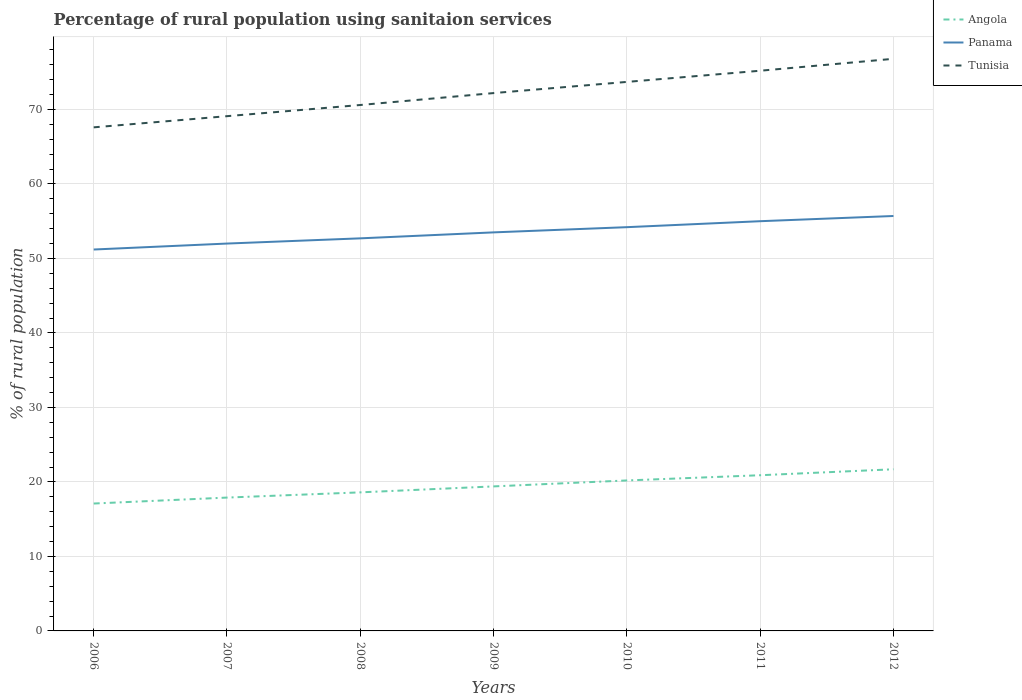How many different coloured lines are there?
Your answer should be very brief. 3. Is the number of lines equal to the number of legend labels?
Your answer should be very brief. Yes. Across all years, what is the maximum percentage of rural population using sanitaion services in Tunisia?
Your answer should be compact. 67.6. What is the total percentage of rural population using sanitaion services in Panama in the graph?
Your answer should be very brief. -0.8. What is the difference between the highest and the second highest percentage of rural population using sanitaion services in Tunisia?
Keep it short and to the point. 9.2. What is the difference between the highest and the lowest percentage of rural population using sanitaion services in Tunisia?
Keep it short and to the point. 4. Is the percentage of rural population using sanitaion services in Panama strictly greater than the percentage of rural population using sanitaion services in Tunisia over the years?
Provide a succinct answer. Yes. How many lines are there?
Keep it short and to the point. 3. How many years are there in the graph?
Your response must be concise. 7. How many legend labels are there?
Make the answer very short. 3. What is the title of the graph?
Provide a succinct answer. Percentage of rural population using sanitaion services. Does "Norway" appear as one of the legend labels in the graph?
Your response must be concise. No. What is the label or title of the Y-axis?
Offer a very short reply. % of rural population. What is the % of rural population in Angola in 2006?
Provide a succinct answer. 17.1. What is the % of rural population of Panama in 2006?
Offer a very short reply. 51.2. What is the % of rural population in Tunisia in 2006?
Provide a short and direct response. 67.6. What is the % of rural population of Tunisia in 2007?
Offer a very short reply. 69.1. What is the % of rural population in Panama in 2008?
Give a very brief answer. 52.7. What is the % of rural population of Tunisia in 2008?
Provide a succinct answer. 70.6. What is the % of rural population in Angola in 2009?
Your response must be concise. 19.4. What is the % of rural population in Panama in 2009?
Offer a very short reply. 53.5. What is the % of rural population of Tunisia in 2009?
Keep it short and to the point. 72.2. What is the % of rural population in Angola in 2010?
Your response must be concise. 20.2. What is the % of rural population of Panama in 2010?
Provide a succinct answer. 54.2. What is the % of rural population in Tunisia in 2010?
Your answer should be very brief. 73.7. What is the % of rural population in Angola in 2011?
Your answer should be compact. 20.9. What is the % of rural population of Panama in 2011?
Your response must be concise. 55. What is the % of rural population in Tunisia in 2011?
Your answer should be very brief. 75.2. What is the % of rural population of Angola in 2012?
Give a very brief answer. 21.7. What is the % of rural population of Panama in 2012?
Your answer should be compact. 55.7. What is the % of rural population in Tunisia in 2012?
Provide a succinct answer. 76.8. Across all years, what is the maximum % of rural population of Angola?
Your response must be concise. 21.7. Across all years, what is the maximum % of rural population in Panama?
Your answer should be compact. 55.7. Across all years, what is the maximum % of rural population in Tunisia?
Provide a succinct answer. 76.8. Across all years, what is the minimum % of rural population of Panama?
Offer a very short reply. 51.2. Across all years, what is the minimum % of rural population of Tunisia?
Give a very brief answer. 67.6. What is the total % of rural population in Angola in the graph?
Ensure brevity in your answer.  135.8. What is the total % of rural population in Panama in the graph?
Provide a succinct answer. 374.3. What is the total % of rural population of Tunisia in the graph?
Your answer should be very brief. 505.2. What is the difference between the % of rural population of Tunisia in 2006 and that in 2007?
Provide a succinct answer. -1.5. What is the difference between the % of rural population in Angola in 2006 and that in 2008?
Keep it short and to the point. -1.5. What is the difference between the % of rural population of Panama in 2006 and that in 2008?
Your response must be concise. -1.5. What is the difference between the % of rural population in Tunisia in 2006 and that in 2008?
Give a very brief answer. -3. What is the difference between the % of rural population of Panama in 2006 and that in 2009?
Your answer should be very brief. -2.3. What is the difference between the % of rural population of Angola in 2006 and that in 2010?
Your answer should be compact. -3.1. What is the difference between the % of rural population in Panama in 2006 and that in 2010?
Offer a terse response. -3. What is the difference between the % of rural population of Panama in 2006 and that in 2012?
Give a very brief answer. -4.5. What is the difference between the % of rural population in Panama in 2007 and that in 2008?
Offer a very short reply. -0.7. What is the difference between the % of rural population in Tunisia in 2007 and that in 2008?
Offer a very short reply. -1.5. What is the difference between the % of rural population of Panama in 2007 and that in 2009?
Your answer should be compact. -1.5. What is the difference between the % of rural population of Tunisia in 2007 and that in 2009?
Your response must be concise. -3.1. What is the difference between the % of rural population in Angola in 2007 and that in 2010?
Your answer should be compact. -2.3. What is the difference between the % of rural population of Tunisia in 2007 and that in 2010?
Provide a short and direct response. -4.6. What is the difference between the % of rural population in Angola in 2007 and that in 2011?
Your answer should be compact. -3. What is the difference between the % of rural population in Angola in 2007 and that in 2012?
Make the answer very short. -3.8. What is the difference between the % of rural population of Panama in 2007 and that in 2012?
Make the answer very short. -3.7. What is the difference between the % of rural population of Tunisia in 2007 and that in 2012?
Ensure brevity in your answer.  -7.7. What is the difference between the % of rural population in Panama in 2008 and that in 2009?
Offer a terse response. -0.8. What is the difference between the % of rural population of Tunisia in 2008 and that in 2009?
Ensure brevity in your answer.  -1.6. What is the difference between the % of rural population of Panama in 2008 and that in 2010?
Your response must be concise. -1.5. What is the difference between the % of rural population of Panama in 2008 and that in 2011?
Your answer should be compact. -2.3. What is the difference between the % of rural population of Angola in 2009 and that in 2010?
Offer a terse response. -0.8. What is the difference between the % of rural population of Panama in 2009 and that in 2011?
Ensure brevity in your answer.  -1.5. What is the difference between the % of rural population of Angola in 2009 and that in 2012?
Offer a very short reply. -2.3. What is the difference between the % of rural population of Panama in 2009 and that in 2012?
Make the answer very short. -2.2. What is the difference between the % of rural population in Tunisia in 2009 and that in 2012?
Give a very brief answer. -4.6. What is the difference between the % of rural population of Angola in 2010 and that in 2011?
Your response must be concise. -0.7. What is the difference between the % of rural population in Panama in 2010 and that in 2011?
Ensure brevity in your answer.  -0.8. What is the difference between the % of rural population of Tunisia in 2010 and that in 2011?
Provide a short and direct response. -1.5. What is the difference between the % of rural population in Angola in 2010 and that in 2012?
Offer a terse response. -1.5. What is the difference between the % of rural population in Panama in 2010 and that in 2012?
Your response must be concise. -1.5. What is the difference between the % of rural population in Tunisia in 2010 and that in 2012?
Provide a short and direct response. -3.1. What is the difference between the % of rural population of Angola in 2011 and that in 2012?
Your response must be concise. -0.8. What is the difference between the % of rural population of Tunisia in 2011 and that in 2012?
Your response must be concise. -1.6. What is the difference between the % of rural population in Angola in 2006 and the % of rural population in Panama in 2007?
Provide a succinct answer. -34.9. What is the difference between the % of rural population of Angola in 2006 and the % of rural population of Tunisia in 2007?
Your answer should be compact. -52. What is the difference between the % of rural population in Panama in 2006 and the % of rural population in Tunisia in 2007?
Provide a short and direct response. -17.9. What is the difference between the % of rural population of Angola in 2006 and the % of rural population of Panama in 2008?
Give a very brief answer. -35.6. What is the difference between the % of rural population in Angola in 2006 and the % of rural population in Tunisia in 2008?
Provide a short and direct response. -53.5. What is the difference between the % of rural population in Panama in 2006 and the % of rural population in Tunisia in 2008?
Your answer should be very brief. -19.4. What is the difference between the % of rural population of Angola in 2006 and the % of rural population of Panama in 2009?
Keep it short and to the point. -36.4. What is the difference between the % of rural population of Angola in 2006 and the % of rural population of Tunisia in 2009?
Give a very brief answer. -55.1. What is the difference between the % of rural population in Panama in 2006 and the % of rural population in Tunisia in 2009?
Make the answer very short. -21. What is the difference between the % of rural population of Angola in 2006 and the % of rural population of Panama in 2010?
Keep it short and to the point. -37.1. What is the difference between the % of rural population in Angola in 2006 and the % of rural population in Tunisia in 2010?
Keep it short and to the point. -56.6. What is the difference between the % of rural population of Panama in 2006 and the % of rural population of Tunisia in 2010?
Your answer should be very brief. -22.5. What is the difference between the % of rural population in Angola in 2006 and the % of rural population in Panama in 2011?
Give a very brief answer. -37.9. What is the difference between the % of rural population in Angola in 2006 and the % of rural population in Tunisia in 2011?
Ensure brevity in your answer.  -58.1. What is the difference between the % of rural population in Angola in 2006 and the % of rural population in Panama in 2012?
Offer a terse response. -38.6. What is the difference between the % of rural population in Angola in 2006 and the % of rural population in Tunisia in 2012?
Offer a terse response. -59.7. What is the difference between the % of rural population of Panama in 2006 and the % of rural population of Tunisia in 2012?
Provide a succinct answer. -25.6. What is the difference between the % of rural population in Angola in 2007 and the % of rural population in Panama in 2008?
Make the answer very short. -34.8. What is the difference between the % of rural population of Angola in 2007 and the % of rural population of Tunisia in 2008?
Give a very brief answer. -52.7. What is the difference between the % of rural population in Panama in 2007 and the % of rural population in Tunisia in 2008?
Your response must be concise. -18.6. What is the difference between the % of rural population of Angola in 2007 and the % of rural population of Panama in 2009?
Your answer should be compact. -35.6. What is the difference between the % of rural population in Angola in 2007 and the % of rural population in Tunisia in 2009?
Provide a succinct answer. -54.3. What is the difference between the % of rural population in Panama in 2007 and the % of rural population in Tunisia in 2009?
Provide a short and direct response. -20.2. What is the difference between the % of rural population of Angola in 2007 and the % of rural population of Panama in 2010?
Keep it short and to the point. -36.3. What is the difference between the % of rural population of Angola in 2007 and the % of rural population of Tunisia in 2010?
Your response must be concise. -55.8. What is the difference between the % of rural population in Panama in 2007 and the % of rural population in Tunisia in 2010?
Your response must be concise. -21.7. What is the difference between the % of rural population in Angola in 2007 and the % of rural population in Panama in 2011?
Provide a short and direct response. -37.1. What is the difference between the % of rural population of Angola in 2007 and the % of rural population of Tunisia in 2011?
Give a very brief answer. -57.3. What is the difference between the % of rural population in Panama in 2007 and the % of rural population in Tunisia in 2011?
Your answer should be compact. -23.2. What is the difference between the % of rural population of Angola in 2007 and the % of rural population of Panama in 2012?
Offer a terse response. -37.8. What is the difference between the % of rural population in Angola in 2007 and the % of rural population in Tunisia in 2012?
Ensure brevity in your answer.  -58.9. What is the difference between the % of rural population of Panama in 2007 and the % of rural population of Tunisia in 2012?
Provide a short and direct response. -24.8. What is the difference between the % of rural population of Angola in 2008 and the % of rural population of Panama in 2009?
Make the answer very short. -34.9. What is the difference between the % of rural population in Angola in 2008 and the % of rural population in Tunisia in 2009?
Your response must be concise. -53.6. What is the difference between the % of rural population of Panama in 2008 and the % of rural population of Tunisia in 2009?
Make the answer very short. -19.5. What is the difference between the % of rural population of Angola in 2008 and the % of rural population of Panama in 2010?
Provide a short and direct response. -35.6. What is the difference between the % of rural population of Angola in 2008 and the % of rural population of Tunisia in 2010?
Give a very brief answer. -55.1. What is the difference between the % of rural population of Angola in 2008 and the % of rural population of Panama in 2011?
Provide a short and direct response. -36.4. What is the difference between the % of rural population in Angola in 2008 and the % of rural population in Tunisia in 2011?
Your response must be concise. -56.6. What is the difference between the % of rural population in Panama in 2008 and the % of rural population in Tunisia in 2011?
Provide a short and direct response. -22.5. What is the difference between the % of rural population in Angola in 2008 and the % of rural population in Panama in 2012?
Provide a short and direct response. -37.1. What is the difference between the % of rural population of Angola in 2008 and the % of rural population of Tunisia in 2012?
Your response must be concise. -58.2. What is the difference between the % of rural population in Panama in 2008 and the % of rural population in Tunisia in 2012?
Provide a short and direct response. -24.1. What is the difference between the % of rural population in Angola in 2009 and the % of rural population in Panama in 2010?
Give a very brief answer. -34.8. What is the difference between the % of rural population in Angola in 2009 and the % of rural population in Tunisia in 2010?
Ensure brevity in your answer.  -54.3. What is the difference between the % of rural population of Panama in 2009 and the % of rural population of Tunisia in 2010?
Your response must be concise. -20.2. What is the difference between the % of rural population in Angola in 2009 and the % of rural population in Panama in 2011?
Provide a succinct answer. -35.6. What is the difference between the % of rural population of Angola in 2009 and the % of rural population of Tunisia in 2011?
Make the answer very short. -55.8. What is the difference between the % of rural population of Panama in 2009 and the % of rural population of Tunisia in 2011?
Make the answer very short. -21.7. What is the difference between the % of rural population of Angola in 2009 and the % of rural population of Panama in 2012?
Offer a very short reply. -36.3. What is the difference between the % of rural population of Angola in 2009 and the % of rural population of Tunisia in 2012?
Offer a very short reply. -57.4. What is the difference between the % of rural population in Panama in 2009 and the % of rural population in Tunisia in 2012?
Keep it short and to the point. -23.3. What is the difference between the % of rural population of Angola in 2010 and the % of rural population of Panama in 2011?
Offer a terse response. -34.8. What is the difference between the % of rural population in Angola in 2010 and the % of rural population in Tunisia in 2011?
Provide a succinct answer. -55. What is the difference between the % of rural population of Panama in 2010 and the % of rural population of Tunisia in 2011?
Offer a very short reply. -21. What is the difference between the % of rural population in Angola in 2010 and the % of rural population in Panama in 2012?
Provide a short and direct response. -35.5. What is the difference between the % of rural population of Angola in 2010 and the % of rural population of Tunisia in 2012?
Provide a succinct answer. -56.6. What is the difference between the % of rural population in Panama in 2010 and the % of rural population in Tunisia in 2012?
Offer a terse response. -22.6. What is the difference between the % of rural population of Angola in 2011 and the % of rural population of Panama in 2012?
Your answer should be compact. -34.8. What is the difference between the % of rural population of Angola in 2011 and the % of rural population of Tunisia in 2012?
Your answer should be very brief. -55.9. What is the difference between the % of rural population of Panama in 2011 and the % of rural population of Tunisia in 2012?
Your answer should be compact. -21.8. What is the average % of rural population in Panama per year?
Offer a terse response. 53.47. What is the average % of rural population of Tunisia per year?
Give a very brief answer. 72.17. In the year 2006, what is the difference between the % of rural population in Angola and % of rural population in Panama?
Ensure brevity in your answer.  -34.1. In the year 2006, what is the difference between the % of rural population in Angola and % of rural population in Tunisia?
Provide a succinct answer. -50.5. In the year 2006, what is the difference between the % of rural population of Panama and % of rural population of Tunisia?
Provide a short and direct response. -16.4. In the year 2007, what is the difference between the % of rural population of Angola and % of rural population of Panama?
Keep it short and to the point. -34.1. In the year 2007, what is the difference between the % of rural population of Angola and % of rural population of Tunisia?
Offer a very short reply. -51.2. In the year 2007, what is the difference between the % of rural population of Panama and % of rural population of Tunisia?
Make the answer very short. -17.1. In the year 2008, what is the difference between the % of rural population in Angola and % of rural population in Panama?
Offer a very short reply. -34.1. In the year 2008, what is the difference between the % of rural population in Angola and % of rural population in Tunisia?
Keep it short and to the point. -52. In the year 2008, what is the difference between the % of rural population of Panama and % of rural population of Tunisia?
Offer a terse response. -17.9. In the year 2009, what is the difference between the % of rural population in Angola and % of rural population in Panama?
Make the answer very short. -34.1. In the year 2009, what is the difference between the % of rural population in Angola and % of rural population in Tunisia?
Give a very brief answer. -52.8. In the year 2009, what is the difference between the % of rural population of Panama and % of rural population of Tunisia?
Your response must be concise. -18.7. In the year 2010, what is the difference between the % of rural population of Angola and % of rural population of Panama?
Keep it short and to the point. -34. In the year 2010, what is the difference between the % of rural population in Angola and % of rural population in Tunisia?
Offer a terse response. -53.5. In the year 2010, what is the difference between the % of rural population of Panama and % of rural population of Tunisia?
Give a very brief answer. -19.5. In the year 2011, what is the difference between the % of rural population in Angola and % of rural population in Panama?
Offer a terse response. -34.1. In the year 2011, what is the difference between the % of rural population of Angola and % of rural population of Tunisia?
Provide a succinct answer. -54.3. In the year 2011, what is the difference between the % of rural population in Panama and % of rural population in Tunisia?
Your response must be concise. -20.2. In the year 2012, what is the difference between the % of rural population in Angola and % of rural population in Panama?
Offer a terse response. -34. In the year 2012, what is the difference between the % of rural population of Angola and % of rural population of Tunisia?
Provide a succinct answer. -55.1. In the year 2012, what is the difference between the % of rural population of Panama and % of rural population of Tunisia?
Ensure brevity in your answer.  -21.1. What is the ratio of the % of rural population of Angola in 2006 to that in 2007?
Keep it short and to the point. 0.96. What is the ratio of the % of rural population in Panama in 2006 to that in 2007?
Provide a short and direct response. 0.98. What is the ratio of the % of rural population of Tunisia in 2006 to that in 2007?
Provide a succinct answer. 0.98. What is the ratio of the % of rural population in Angola in 2006 to that in 2008?
Offer a very short reply. 0.92. What is the ratio of the % of rural population in Panama in 2006 to that in 2008?
Ensure brevity in your answer.  0.97. What is the ratio of the % of rural population of Tunisia in 2006 to that in 2008?
Offer a terse response. 0.96. What is the ratio of the % of rural population in Angola in 2006 to that in 2009?
Provide a short and direct response. 0.88. What is the ratio of the % of rural population in Panama in 2006 to that in 2009?
Provide a short and direct response. 0.96. What is the ratio of the % of rural population in Tunisia in 2006 to that in 2009?
Offer a very short reply. 0.94. What is the ratio of the % of rural population in Angola in 2006 to that in 2010?
Your answer should be very brief. 0.85. What is the ratio of the % of rural population in Panama in 2006 to that in 2010?
Provide a short and direct response. 0.94. What is the ratio of the % of rural population in Tunisia in 2006 to that in 2010?
Offer a terse response. 0.92. What is the ratio of the % of rural population in Angola in 2006 to that in 2011?
Provide a succinct answer. 0.82. What is the ratio of the % of rural population of Panama in 2006 to that in 2011?
Provide a succinct answer. 0.93. What is the ratio of the % of rural population of Tunisia in 2006 to that in 2011?
Ensure brevity in your answer.  0.9. What is the ratio of the % of rural population of Angola in 2006 to that in 2012?
Your answer should be very brief. 0.79. What is the ratio of the % of rural population in Panama in 2006 to that in 2012?
Offer a terse response. 0.92. What is the ratio of the % of rural population of Tunisia in 2006 to that in 2012?
Provide a short and direct response. 0.88. What is the ratio of the % of rural population of Angola in 2007 to that in 2008?
Provide a short and direct response. 0.96. What is the ratio of the % of rural population in Panama in 2007 to that in 2008?
Your answer should be very brief. 0.99. What is the ratio of the % of rural population in Tunisia in 2007 to that in 2008?
Make the answer very short. 0.98. What is the ratio of the % of rural population of Angola in 2007 to that in 2009?
Provide a short and direct response. 0.92. What is the ratio of the % of rural population in Tunisia in 2007 to that in 2009?
Your answer should be very brief. 0.96. What is the ratio of the % of rural population of Angola in 2007 to that in 2010?
Offer a very short reply. 0.89. What is the ratio of the % of rural population in Panama in 2007 to that in 2010?
Ensure brevity in your answer.  0.96. What is the ratio of the % of rural population in Tunisia in 2007 to that in 2010?
Make the answer very short. 0.94. What is the ratio of the % of rural population of Angola in 2007 to that in 2011?
Give a very brief answer. 0.86. What is the ratio of the % of rural population of Panama in 2007 to that in 2011?
Your answer should be compact. 0.95. What is the ratio of the % of rural population of Tunisia in 2007 to that in 2011?
Offer a very short reply. 0.92. What is the ratio of the % of rural population in Angola in 2007 to that in 2012?
Provide a succinct answer. 0.82. What is the ratio of the % of rural population of Panama in 2007 to that in 2012?
Your answer should be very brief. 0.93. What is the ratio of the % of rural population in Tunisia in 2007 to that in 2012?
Your response must be concise. 0.9. What is the ratio of the % of rural population in Angola in 2008 to that in 2009?
Give a very brief answer. 0.96. What is the ratio of the % of rural population in Panama in 2008 to that in 2009?
Your answer should be very brief. 0.98. What is the ratio of the % of rural population of Tunisia in 2008 to that in 2009?
Ensure brevity in your answer.  0.98. What is the ratio of the % of rural population in Angola in 2008 to that in 2010?
Offer a terse response. 0.92. What is the ratio of the % of rural population in Panama in 2008 to that in 2010?
Your response must be concise. 0.97. What is the ratio of the % of rural population in Tunisia in 2008 to that in 2010?
Offer a very short reply. 0.96. What is the ratio of the % of rural population of Angola in 2008 to that in 2011?
Your answer should be compact. 0.89. What is the ratio of the % of rural population in Panama in 2008 to that in 2011?
Give a very brief answer. 0.96. What is the ratio of the % of rural population of Tunisia in 2008 to that in 2011?
Your answer should be compact. 0.94. What is the ratio of the % of rural population in Panama in 2008 to that in 2012?
Give a very brief answer. 0.95. What is the ratio of the % of rural population in Tunisia in 2008 to that in 2012?
Give a very brief answer. 0.92. What is the ratio of the % of rural population in Angola in 2009 to that in 2010?
Ensure brevity in your answer.  0.96. What is the ratio of the % of rural population in Panama in 2009 to that in 2010?
Provide a succinct answer. 0.99. What is the ratio of the % of rural population of Tunisia in 2009 to that in 2010?
Offer a terse response. 0.98. What is the ratio of the % of rural population in Angola in 2009 to that in 2011?
Your answer should be compact. 0.93. What is the ratio of the % of rural population in Panama in 2009 to that in 2011?
Provide a short and direct response. 0.97. What is the ratio of the % of rural population in Tunisia in 2009 to that in 2011?
Offer a terse response. 0.96. What is the ratio of the % of rural population of Angola in 2009 to that in 2012?
Your answer should be compact. 0.89. What is the ratio of the % of rural population in Panama in 2009 to that in 2012?
Keep it short and to the point. 0.96. What is the ratio of the % of rural population of Tunisia in 2009 to that in 2012?
Ensure brevity in your answer.  0.94. What is the ratio of the % of rural population in Angola in 2010 to that in 2011?
Provide a succinct answer. 0.97. What is the ratio of the % of rural population of Panama in 2010 to that in 2011?
Your response must be concise. 0.99. What is the ratio of the % of rural population in Tunisia in 2010 to that in 2011?
Ensure brevity in your answer.  0.98. What is the ratio of the % of rural population in Angola in 2010 to that in 2012?
Ensure brevity in your answer.  0.93. What is the ratio of the % of rural population of Panama in 2010 to that in 2012?
Make the answer very short. 0.97. What is the ratio of the % of rural population in Tunisia in 2010 to that in 2012?
Provide a short and direct response. 0.96. What is the ratio of the % of rural population of Angola in 2011 to that in 2012?
Make the answer very short. 0.96. What is the ratio of the % of rural population in Panama in 2011 to that in 2012?
Ensure brevity in your answer.  0.99. What is the ratio of the % of rural population in Tunisia in 2011 to that in 2012?
Your answer should be compact. 0.98. What is the difference between the highest and the second highest % of rural population in Tunisia?
Offer a terse response. 1.6. 